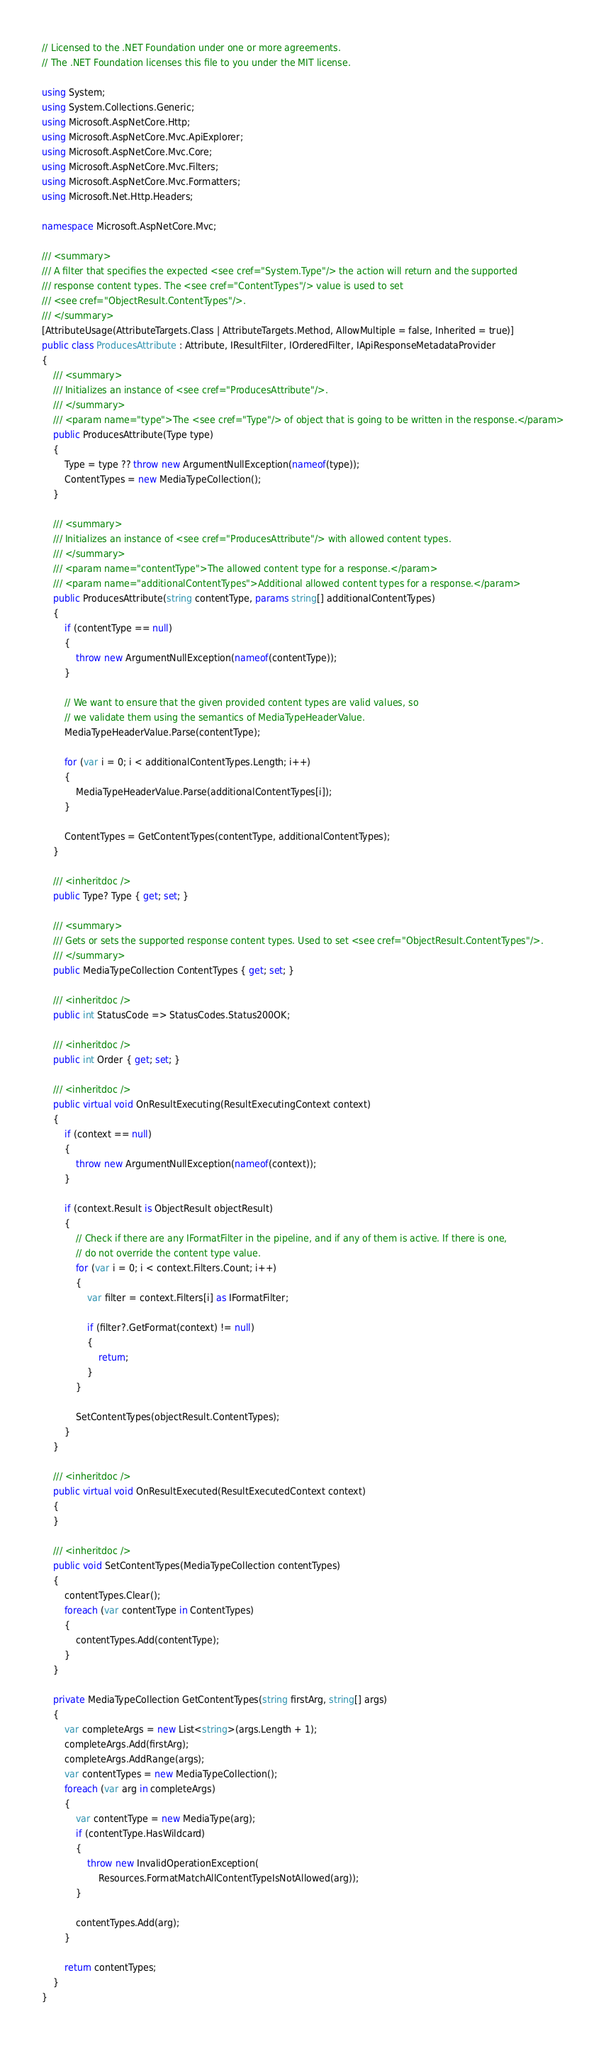<code> <loc_0><loc_0><loc_500><loc_500><_C#_>// Licensed to the .NET Foundation under one or more agreements.
// The .NET Foundation licenses this file to you under the MIT license.

using System;
using System.Collections.Generic;
using Microsoft.AspNetCore.Http;
using Microsoft.AspNetCore.Mvc.ApiExplorer;
using Microsoft.AspNetCore.Mvc.Core;
using Microsoft.AspNetCore.Mvc.Filters;
using Microsoft.AspNetCore.Mvc.Formatters;
using Microsoft.Net.Http.Headers;

namespace Microsoft.AspNetCore.Mvc;

/// <summary>
/// A filter that specifies the expected <see cref="System.Type"/> the action will return and the supported
/// response content types. The <see cref="ContentTypes"/> value is used to set
/// <see cref="ObjectResult.ContentTypes"/>.
/// </summary>
[AttributeUsage(AttributeTargets.Class | AttributeTargets.Method, AllowMultiple = false, Inherited = true)]
public class ProducesAttribute : Attribute, IResultFilter, IOrderedFilter, IApiResponseMetadataProvider
{
    /// <summary>
    /// Initializes an instance of <see cref="ProducesAttribute"/>.
    /// </summary>
    /// <param name="type">The <see cref="Type"/> of object that is going to be written in the response.</param>
    public ProducesAttribute(Type type)
    {
        Type = type ?? throw new ArgumentNullException(nameof(type));
        ContentTypes = new MediaTypeCollection();
    }

    /// <summary>
    /// Initializes an instance of <see cref="ProducesAttribute"/> with allowed content types.
    /// </summary>
    /// <param name="contentType">The allowed content type for a response.</param>
    /// <param name="additionalContentTypes">Additional allowed content types for a response.</param>
    public ProducesAttribute(string contentType, params string[] additionalContentTypes)
    {
        if (contentType == null)
        {
            throw new ArgumentNullException(nameof(contentType));
        }

        // We want to ensure that the given provided content types are valid values, so
        // we validate them using the semantics of MediaTypeHeaderValue.
        MediaTypeHeaderValue.Parse(contentType);

        for (var i = 0; i < additionalContentTypes.Length; i++)
        {
            MediaTypeHeaderValue.Parse(additionalContentTypes[i]);
        }

        ContentTypes = GetContentTypes(contentType, additionalContentTypes);
    }

    /// <inheritdoc />
    public Type? Type { get; set; }

    /// <summary>
    /// Gets or sets the supported response content types. Used to set <see cref="ObjectResult.ContentTypes"/>.
    /// </summary>
    public MediaTypeCollection ContentTypes { get; set; }

    /// <inheritdoc />
    public int StatusCode => StatusCodes.Status200OK;

    /// <inheritdoc />
    public int Order { get; set; }

    /// <inheritdoc />
    public virtual void OnResultExecuting(ResultExecutingContext context)
    {
        if (context == null)
        {
            throw new ArgumentNullException(nameof(context));
        }

        if (context.Result is ObjectResult objectResult)
        {
            // Check if there are any IFormatFilter in the pipeline, and if any of them is active. If there is one,
            // do not override the content type value.
            for (var i = 0; i < context.Filters.Count; i++)
            {
                var filter = context.Filters[i] as IFormatFilter;

                if (filter?.GetFormat(context) != null)
                {
                    return;
                }
            }

            SetContentTypes(objectResult.ContentTypes);
        }
    }

    /// <inheritdoc />
    public virtual void OnResultExecuted(ResultExecutedContext context)
    {
    }

    /// <inheritdoc />
    public void SetContentTypes(MediaTypeCollection contentTypes)
    {
        contentTypes.Clear();
        foreach (var contentType in ContentTypes)
        {
            contentTypes.Add(contentType);
        }
    }

    private MediaTypeCollection GetContentTypes(string firstArg, string[] args)
    {
        var completeArgs = new List<string>(args.Length + 1);
        completeArgs.Add(firstArg);
        completeArgs.AddRange(args);
        var contentTypes = new MediaTypeCollection();
        foreach (var arg in completeArgs)
        {
            var contentType = new MediaType(arg);
            if (contentType.HasWildcard)
            {
                throw new InvalidOperationException(
                    Resources.FormatMatchAllContentTypeIsNotAllowed(arg));
            }

            contentTypes.Add(arg);
        }

        return contentTypes;
    }
}
</code> 